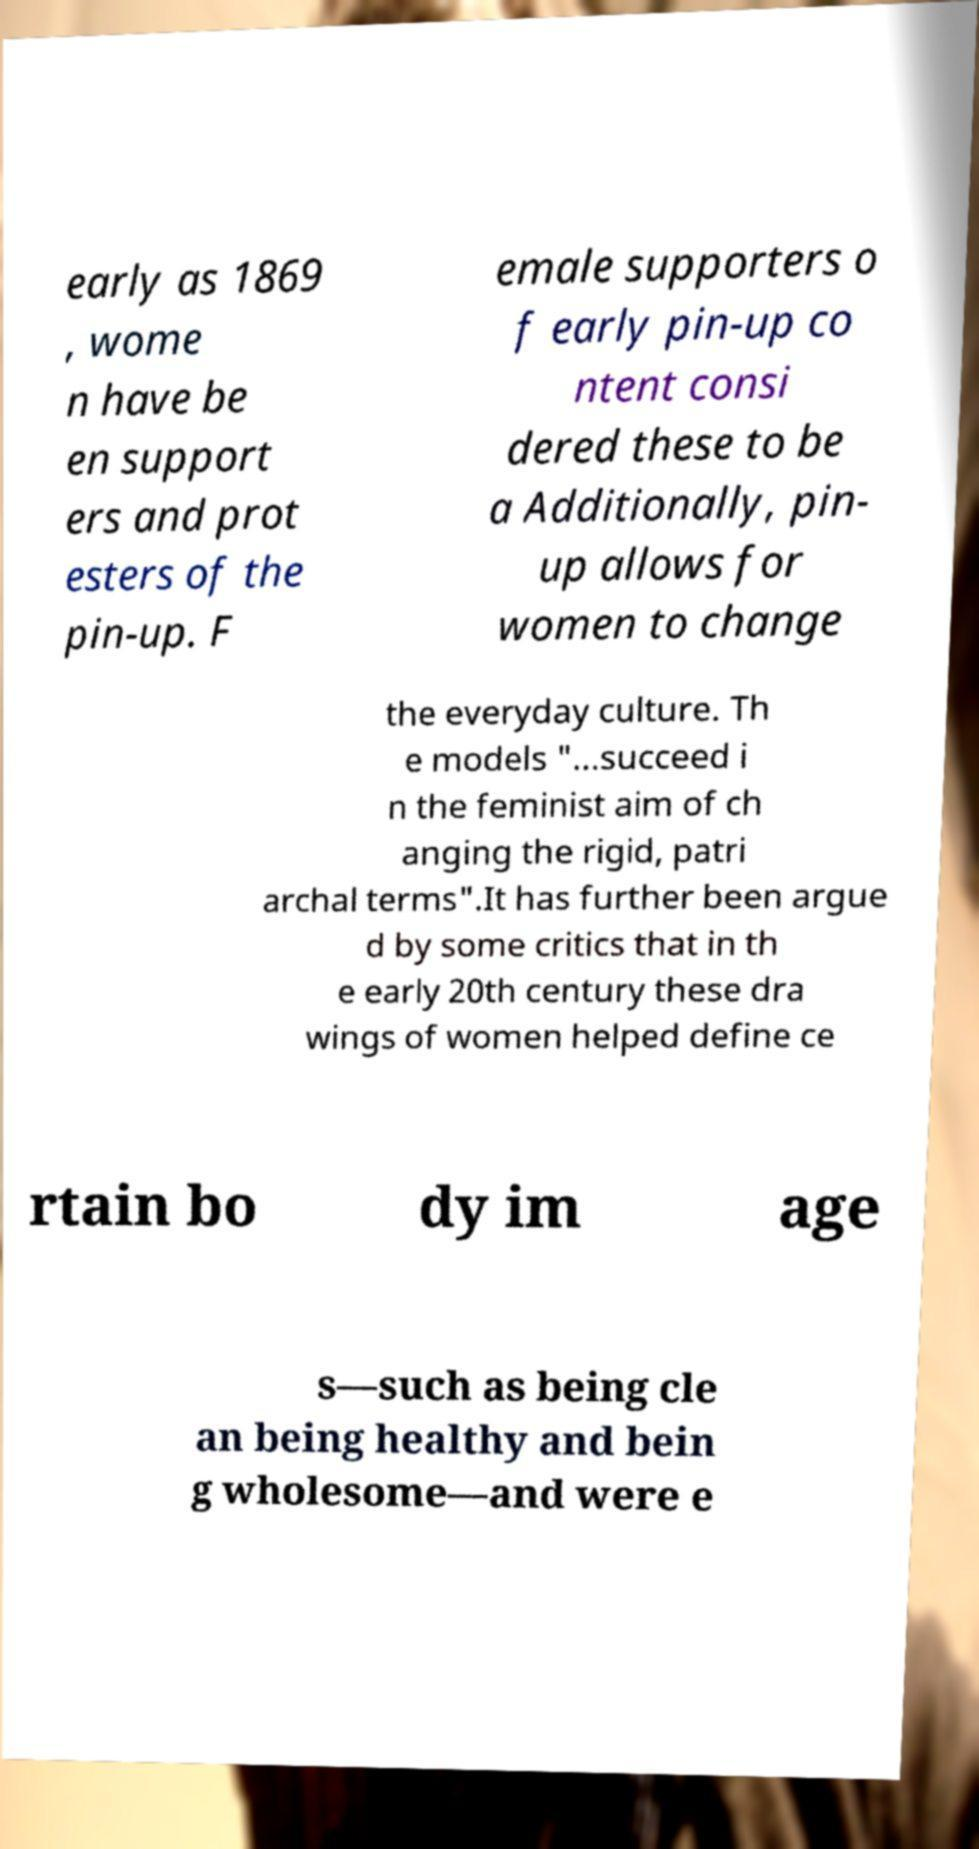Can you accurately transcribe the text from the provided image for me? early as 1869 , wome n have be en support ers and prot esters of the pin-up. F emale supporters o f early pin-up co ntent consi dered these to be a Additionally, pin- up allows for women to change the everyday culture. Th e models "...succeed i n the feminist aim of ch anging the rigid, patri archal terms".It has further been argue d by some critics that in th e early 20th century these dra wings of women helped define ce rtain bo dy im age s—such as being cle an being healthy and bein g wholesome—and were e 